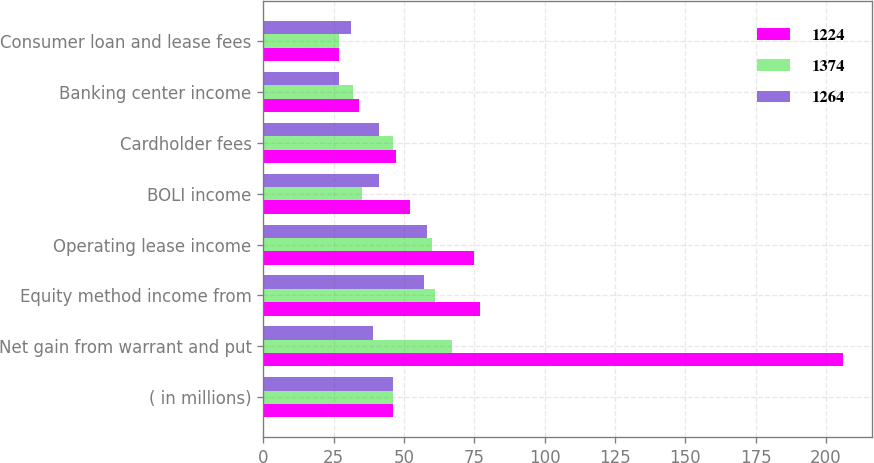<chart> <loc_0><loc_0><loc_500><loc_500><stacked_bar_chart><ecel><fcel>( in millions)<fcel>Net gain from warrant and put<fcel>Equity method income from<fcel>Operating lease income<fcel>BOLI income<fcel>Cardholder fees<fcel>Banking center income<fcel>Consumer loan and lease fees<nl><fcel>1224<fcel>46<fcel>206<fcel>77<fcel>75<fcel>52<fcel>47<fcel>34<fcel>27<nl><fcel>1374<fcel>46<fcel>67<fcel>61<fcel>60<fcel>35<fcel>46<fcel>32<fcel>27<nl><fcel>1264<fcel>46<fcel>39<fcel>57<fcel>58<fcel>41<fcel>41<fcel>27<fcel>31<nl></chart> 